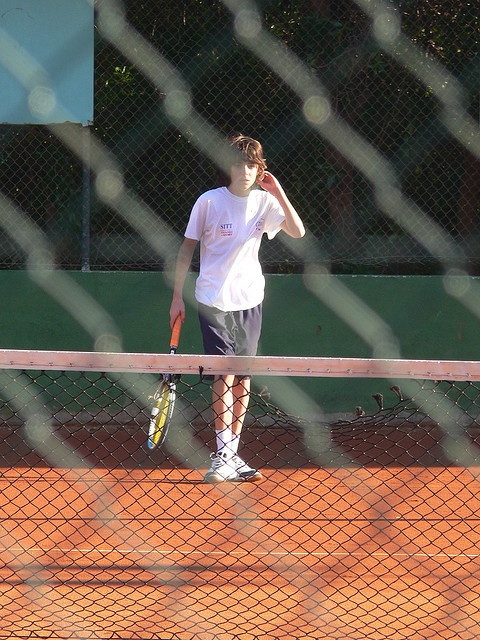Describe the objects in this image and their specific colors. I can see people in teal, white, gray, darkgray, and lavender tones and tennis racket in teal, gray, white, tan, and black tones in this image. 